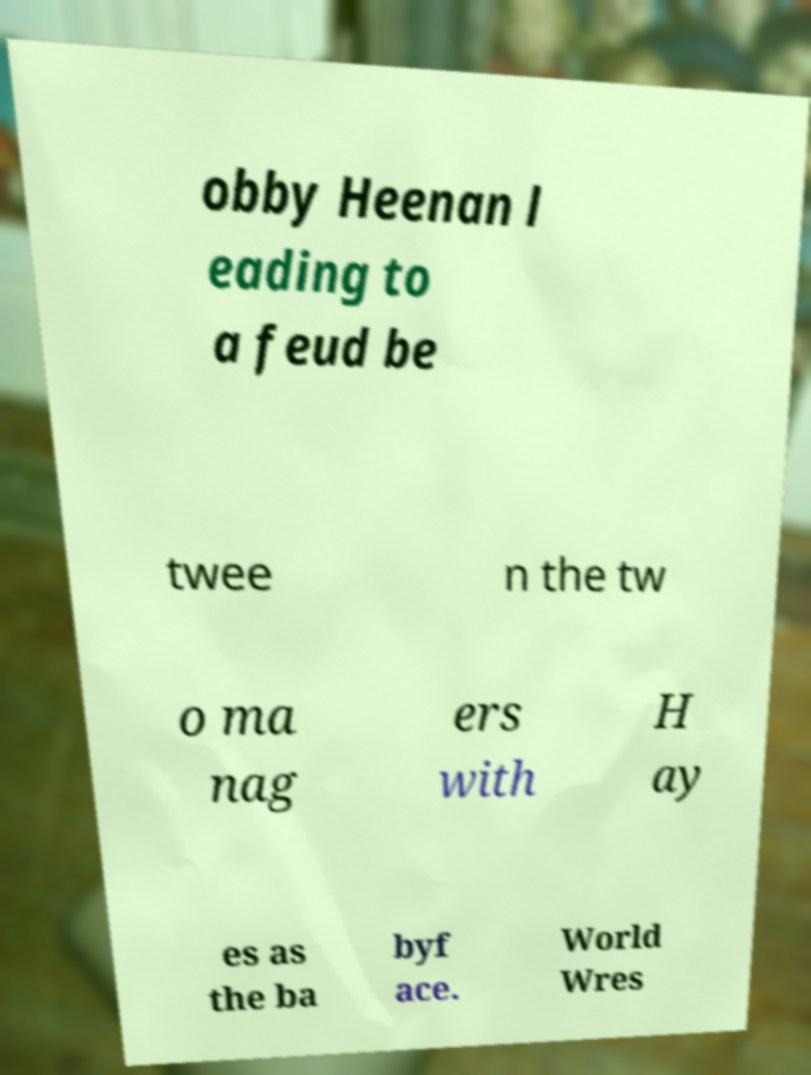Can you accurately transcribe the text from the provided image for me? obby Heenan l eading to a feud be twee n the tw o ma nag ers with H ay es as the ba byf ace. World Wres 